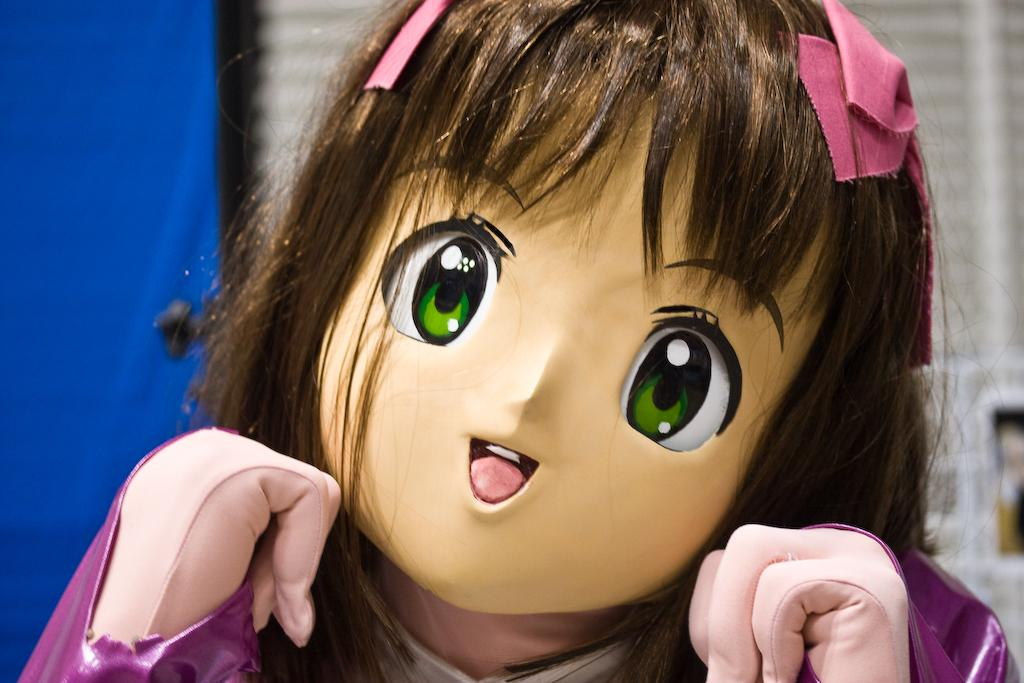What is the main subject of the image? There is a doll in the image. Can you describe the background of the image? The background of the image has white and blue colors. How many seeds are planted in the doll's hair in the image? There are no seeds or any indication of planting in the image; it features a doll with a background of white and blue colors. 